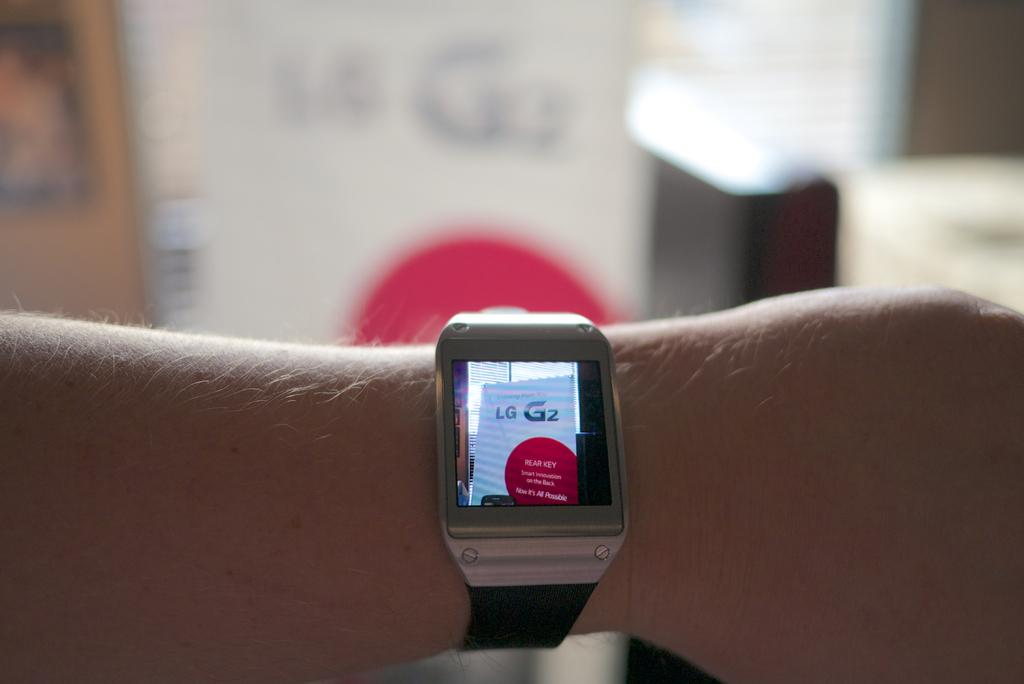<image>
Render a clear and concise summary of the photo. On an arm a smart watch displays a photo of a store display for LG. 